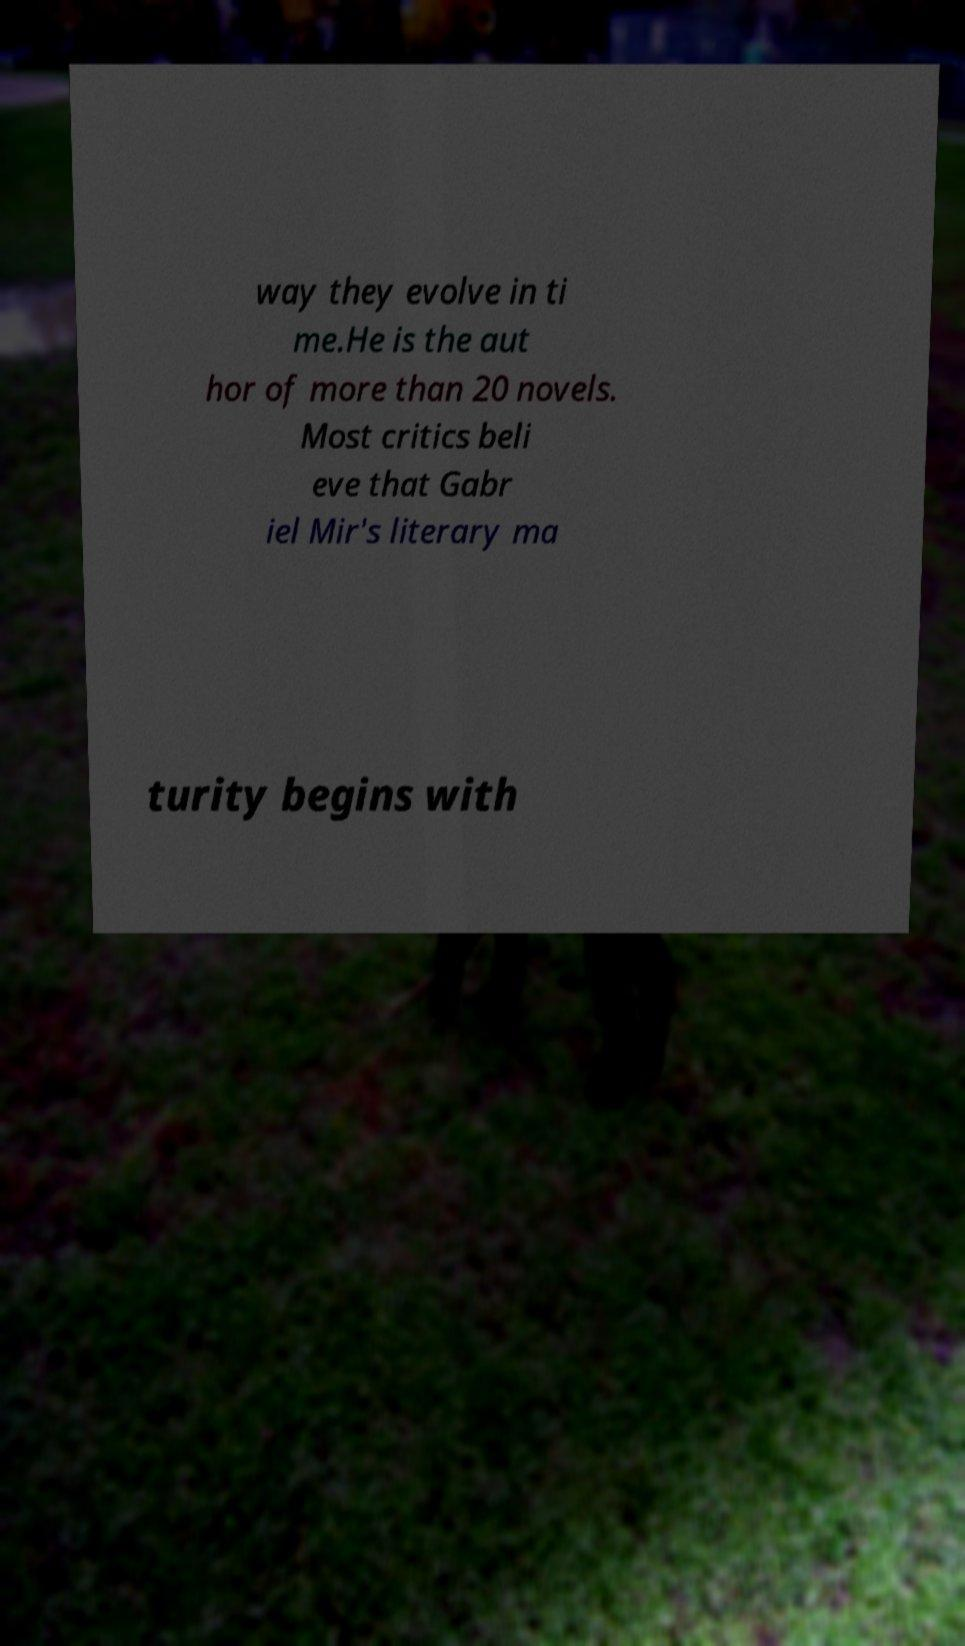Can you accurately transcribe the text from the provided image for me? way they evolve in ti me.He is the aut hor of more than 20 novels. Most critics beli eve that Gabr iel Mir's literary ma turity begins with 